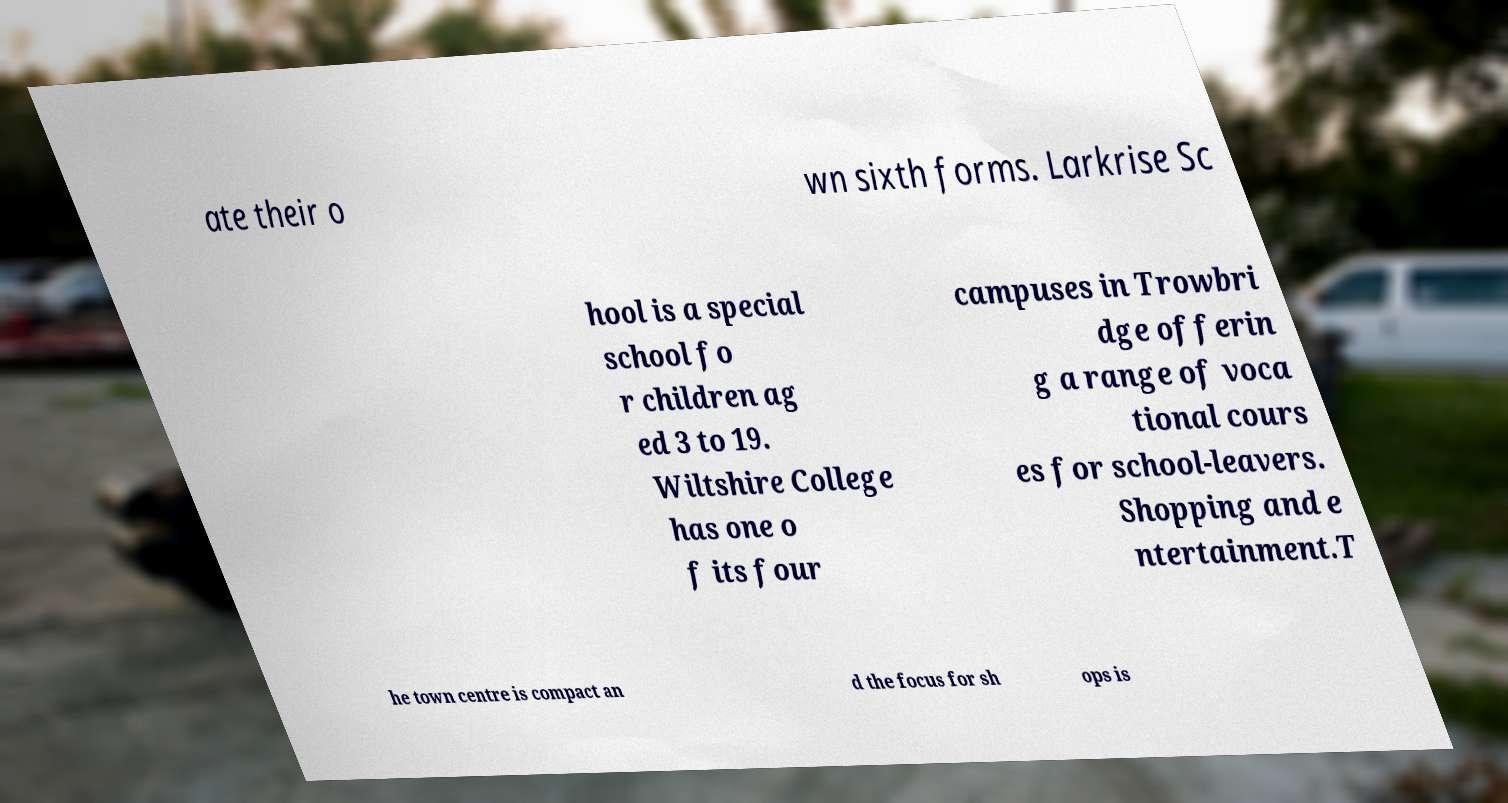I need the written content from this picture converted into text. Can you do that? ate their o wn sixth forms. Larkrise Sc hool is a special school fo r children ag ed 3 to 19. Wiltshire College has one o f its four campuses in Trowbri dge offerin g a range of voca tional cours es for school-leavers. Shopping and e ntertainment.T he town centre is compact an d the focus for sh ops is 